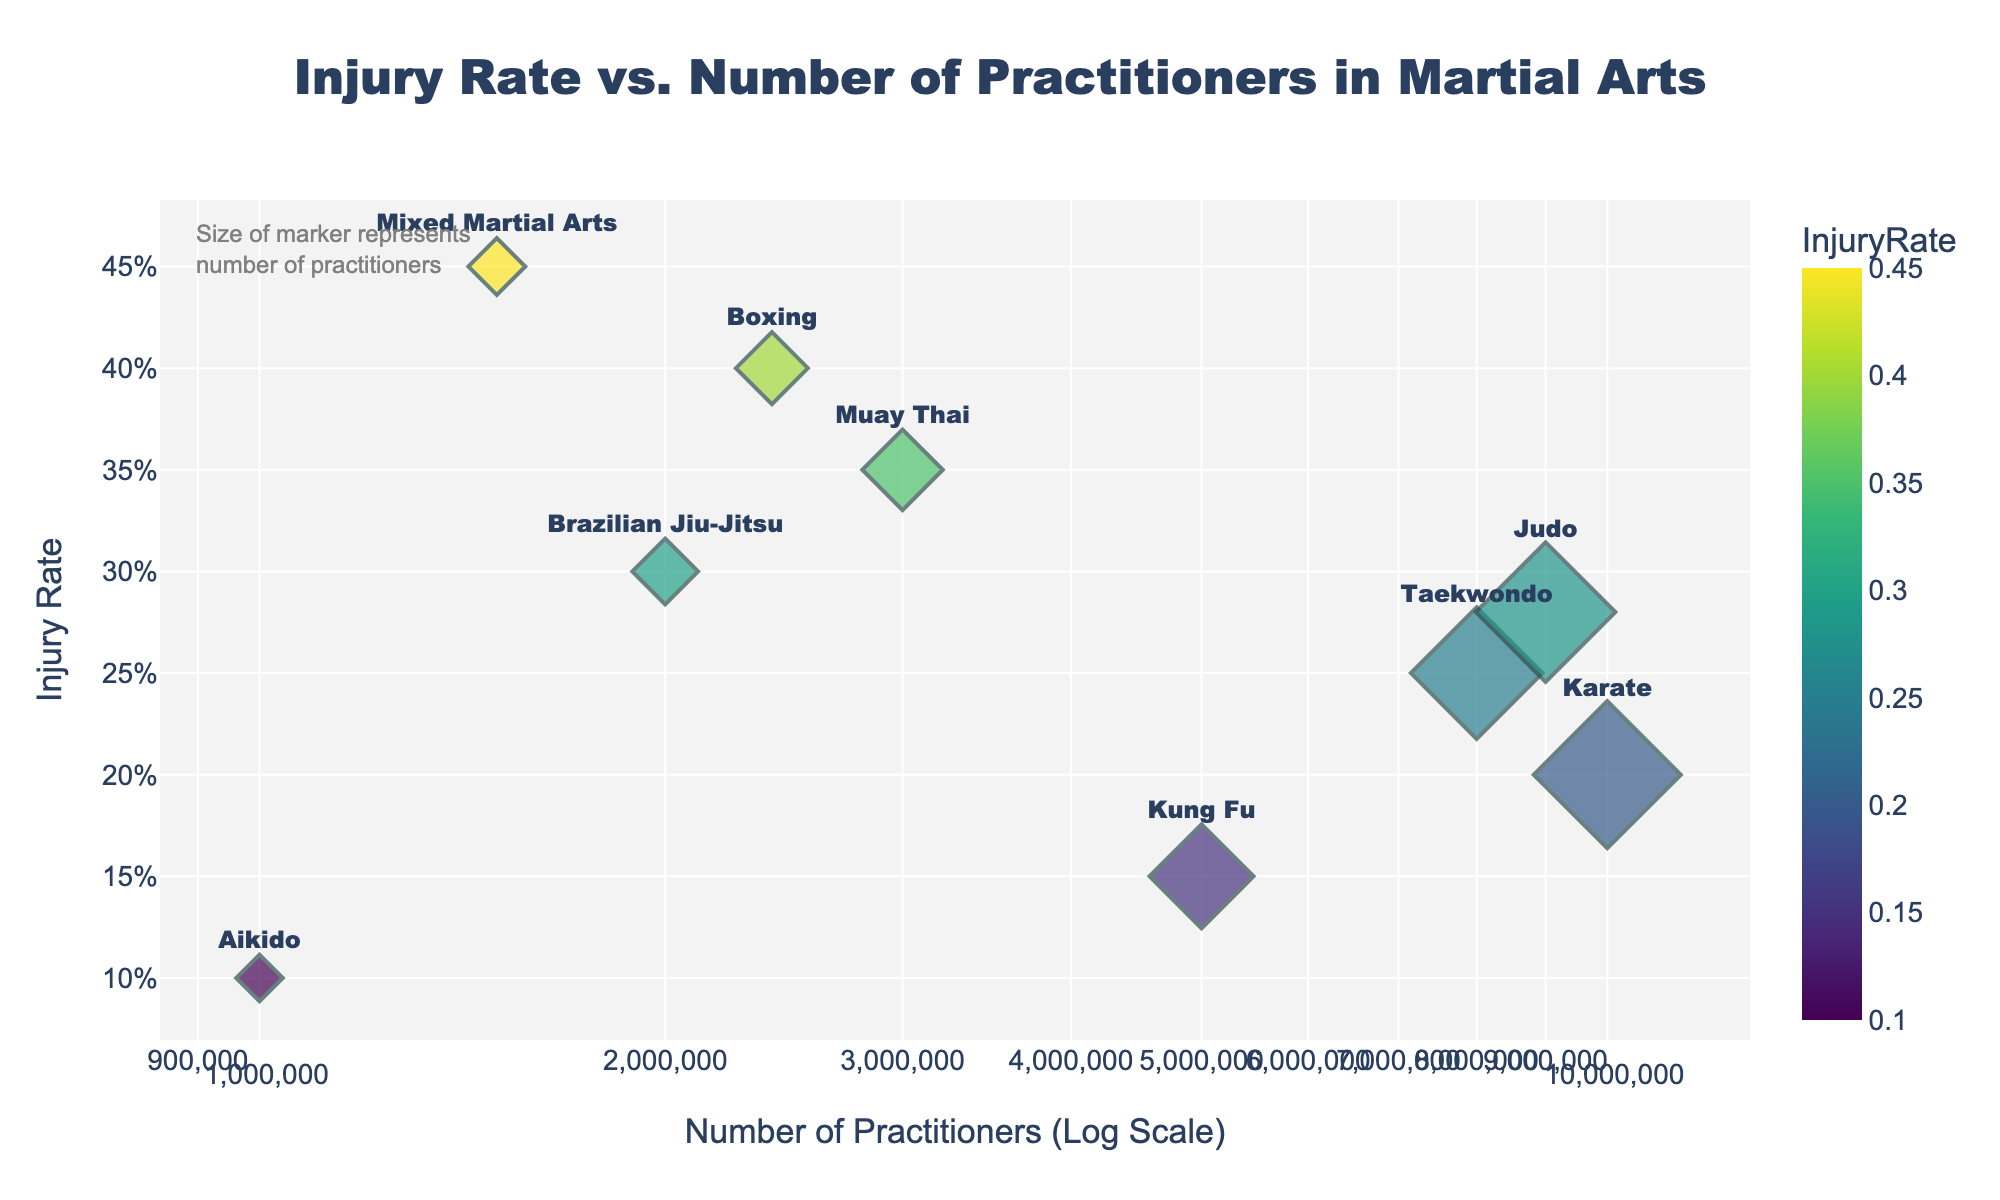What's the title of the figure? The title is placed at the top of the figure, centered and slightly above the plot area. It indicates what the scatter plot is about.
Answer: Injury Rate vs. Number of Practitioners in Martial Arts Which martial art has the highest injury rate? To find the martial art with the highest injury rate, look at the y-axis values and identify the point that reaches the maximum on the vertical scale.
Answer: Mixed Martial Arts What are the axes titles of the figure? The axes titles are located alongside the axes; horizontal for the x-axis and vertical for the y-axis.
Answer: The x-axis title is "Number of Practitioners (Log Scale)" and the y-axis title is "Injury Rate" How many martial arts disciplines are plotted in the figure? To determine the number of disciplines plotted, count the distinct points or labels representing each martial art.
Answer: 9 Which martial art has the lowest number of practitioners? Look at the points on the x-axis and identify which point is at the extreme left, as the x-axis is on a log scale.
Answer: Aikido What's the injury rate difference between Boxing and Karate? Subtract Karate's injury rate from Boxing's injury rate. Karate's rate is 0.2 and Boxing's is 0.4, so 0.4 - 0.2 = 0.2.
Answer: 0.2 Which martial arts have a number of practitioners between 1,000,000 and 2,000,000? Identify points on the x-axis that fall within this range.
Answer: Mixed Martial Arts and Aikido Does any martial art show a lower injury rate but higher number of practitioners compared to another? Compare points visually; Kung Fu and Karate have lower injury rates and higher practitioner numbers than several others.
Answer: Yes, Kung Fu compared to Brazilian Jiu-Jitsu What's the relationship between practitioner numbers and injury rate? By observing the trend, it seems there's no straightforward linear relationship as injury rates vary across different practitioner numbers. This indicates a complex relationship.
Answer: Complex relationship 